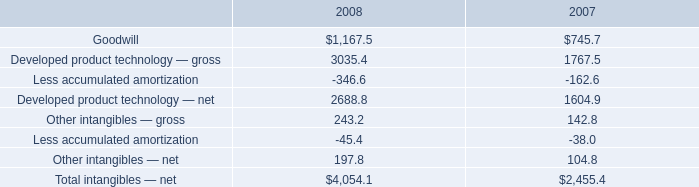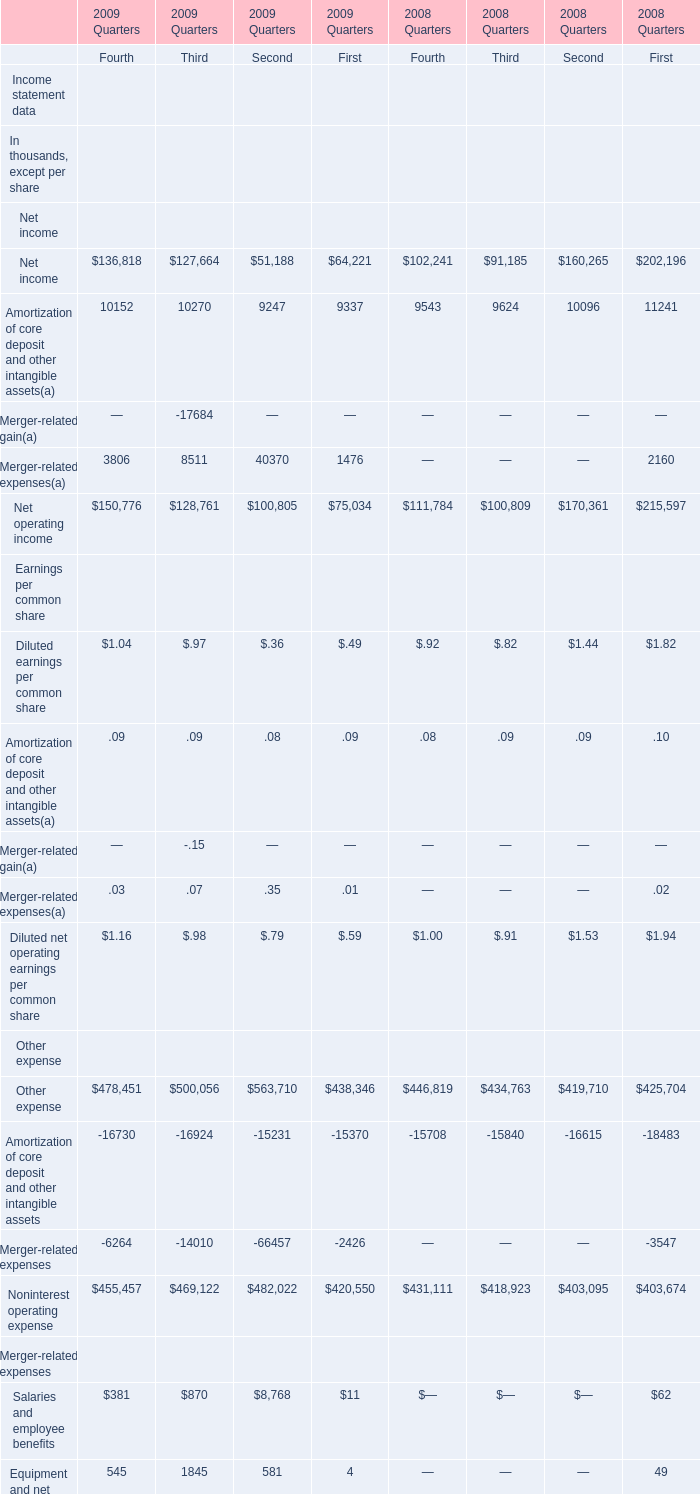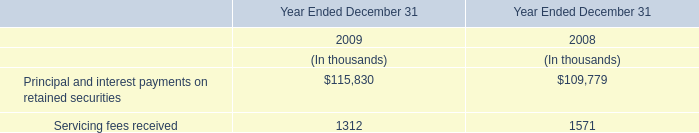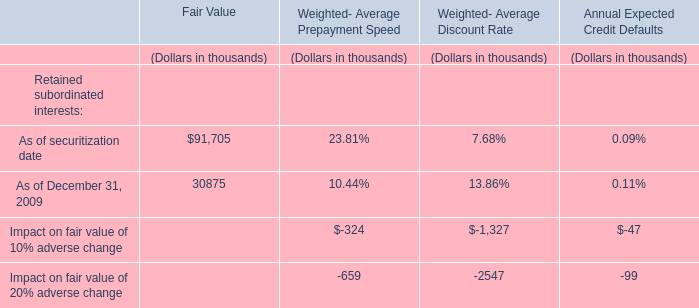what was the percent of increase in the amortization expense from 2007 to 2008 
Computations: ((193.4 - 172.8) / 172.8)
Answer: 0.11921. 